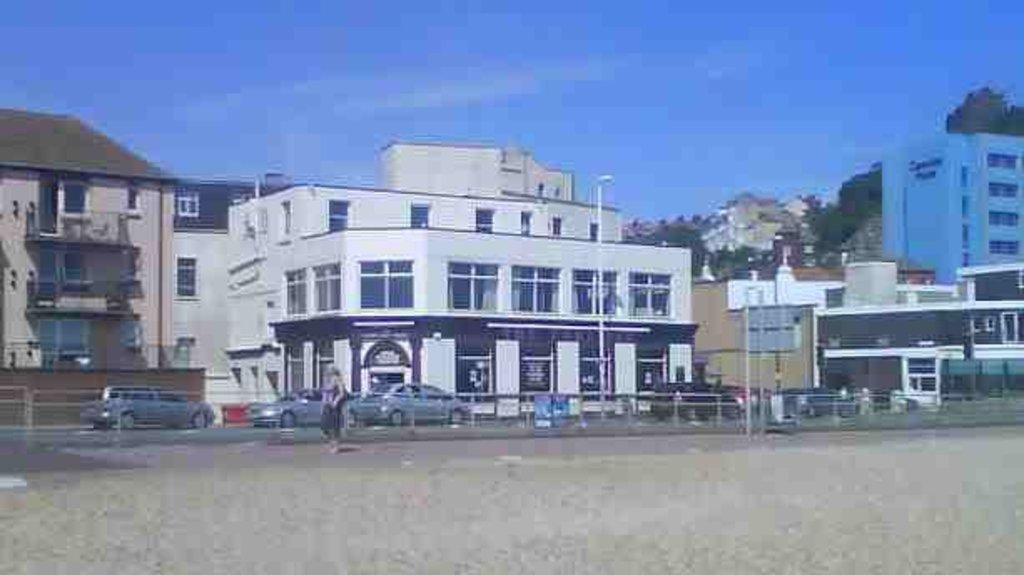Could you give a brief overview of what you see in this image? In the background we can see the sky, trees. In this picture we can see the buildings, windows, light poles, vehicles. A person is also visible in this picture. Bottom portion of the picture is blur. 